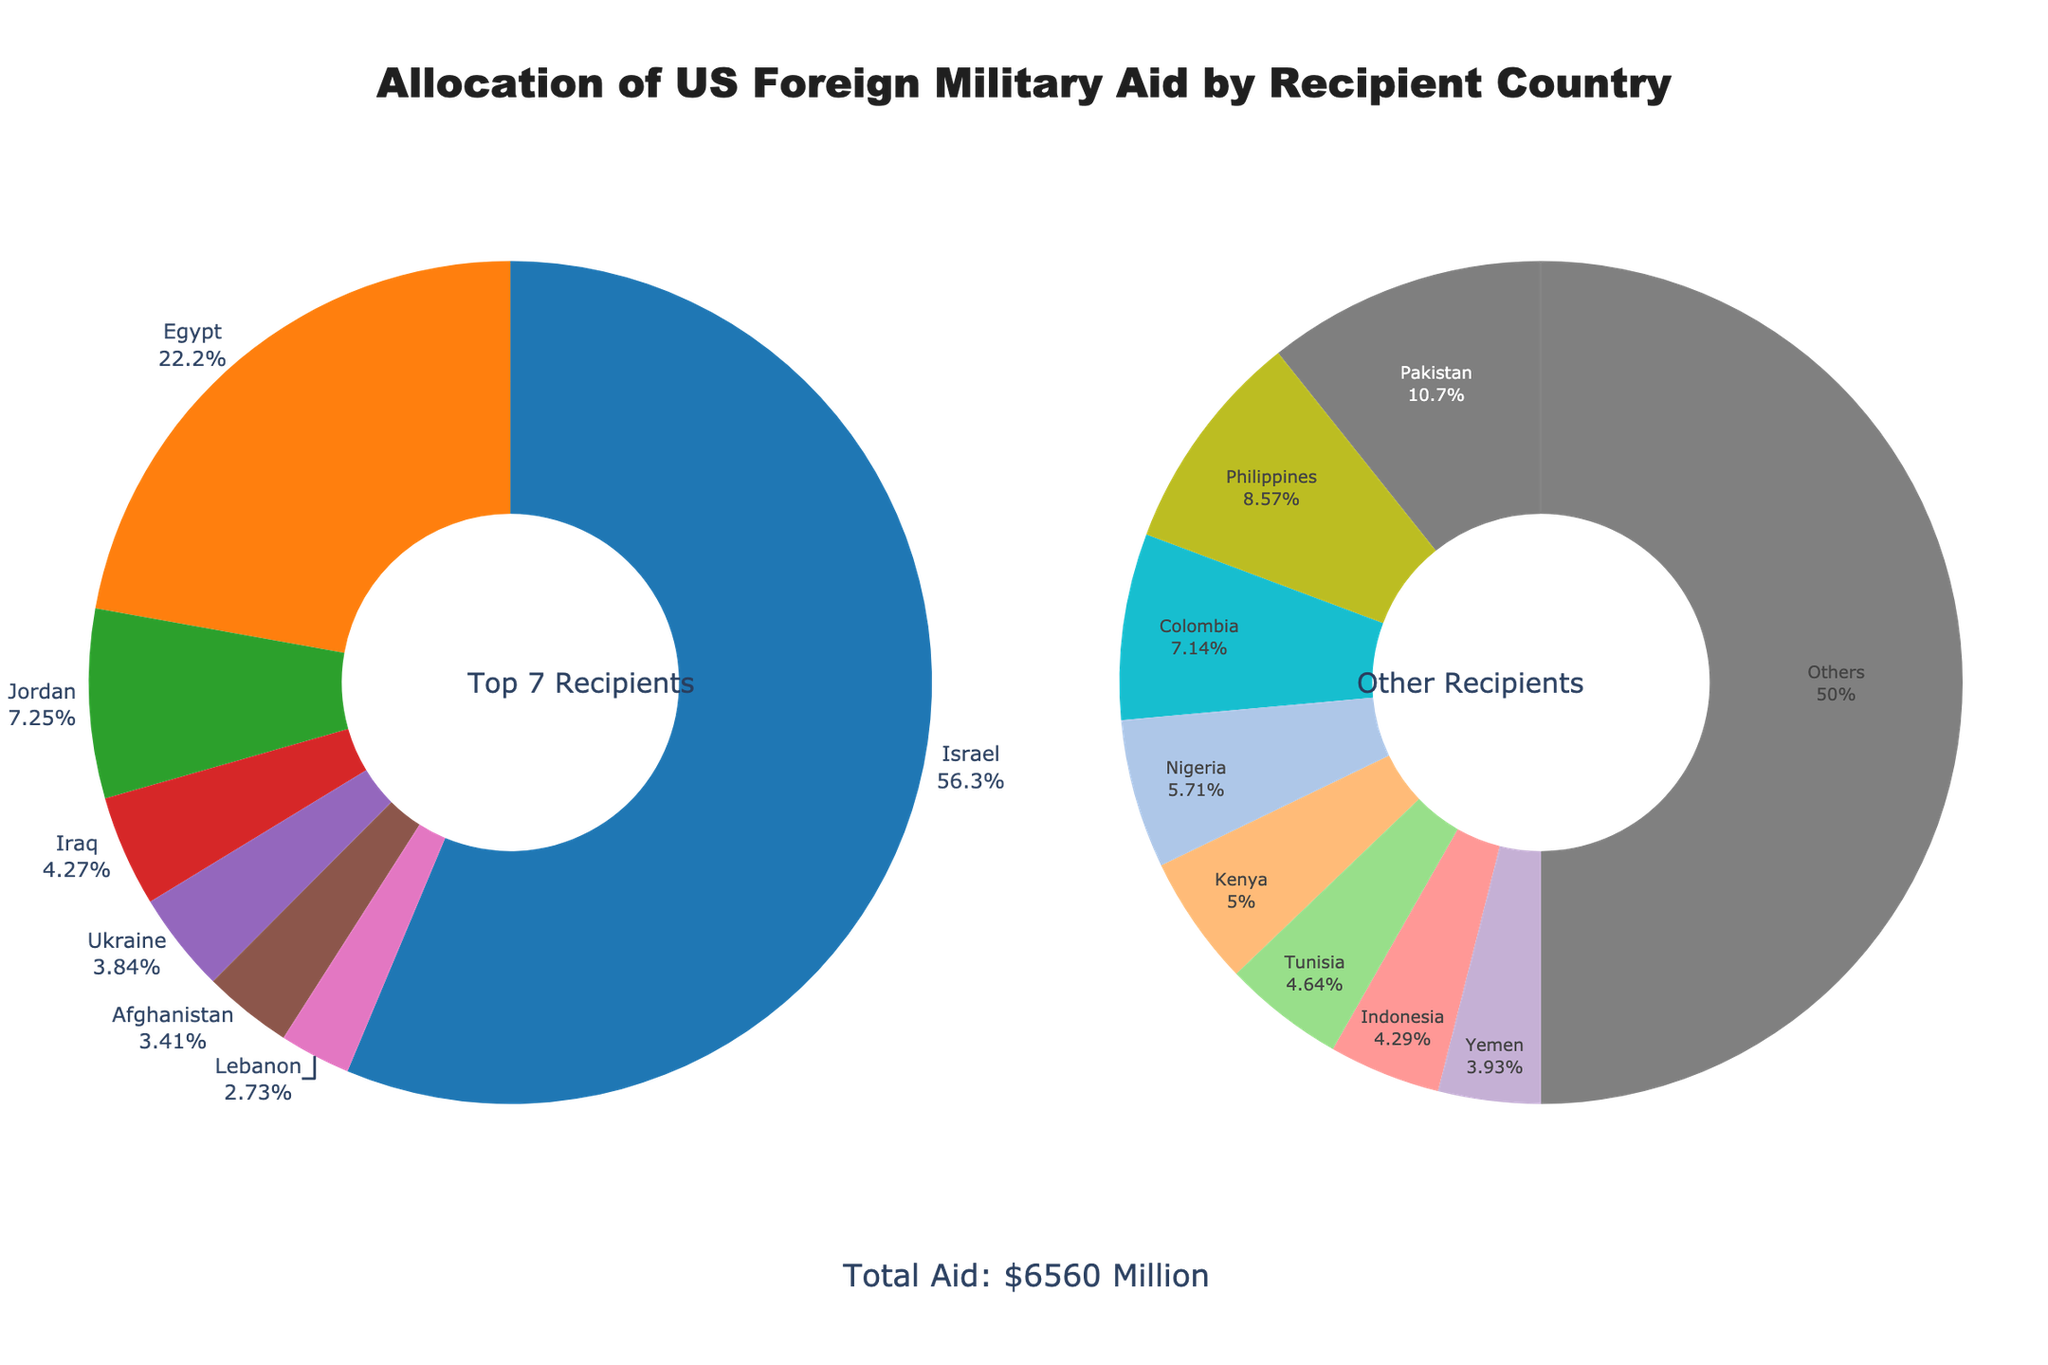Which country receives the highest amount of US foreign military aid? To determine the country receiving the highest amount of aid, look at the main pie chart for the country with the largest slice. Israel comes first with 3300 million USD.
Answer: Israel How much total aid is allocated to the top three recipient countries? Sum the aid amounts for Israel (3300 million USD), Egypt (1300 million USD), and Jordan (425 million USD). Total is 3300 + 1300 + 425 = 5025 million USD.
Answer: 5025 million USD What percentage of total aid does Israel receive? Refer to the percentage shown next to Israel in the main pie chart, or calculate by dividing Israel's aid (3300 million USD) by the total aid (6900 million USD) and then multiplying by 100.
Answer: 47.83% Which two countries receive almost equal amounts of aid? Compare aid amounts visually in the main and secondary pie charts. Pakistan and Philippines receive approximately equal amounts, 150 million USD and 120 million USD respectively.
Answer: Pakistan and Philippines What proportion of the total aid is categorized under "Other Recipients"? Find the second pie chart's slice labeled as "Others". Calculate by dividing the sum of those countries’ aid amounts (960 million USD) by total aid (6900 million USD) and convert to a percentage.
Answer: 13.91% What is the sum of aid given to countries in the "Others" category? The second pie chart visually summarizes "Others". Adding the aid amounts of all countries not in the top 7 gives the sum as 960 million USD. This total is shown as a slice in the "Others" pie chart.
Answer: 960 million USD Which country receives the least foreign military aid among the listed countries? The smallest slice in the secondary pie chart corresponds to Yemen, receiving 55 million USD.
Answer: Yemen How much more aid does Egypt receive compared to Ukraine? Subtract the aid amount for Ukraine (225 million USD) from Egypt’s aid amount (1300 million USD). Calculation: 1300 - 225 = 1075 million USD.
Answer: 1075 million USD Between Afghanistan and Lebanon, which country receives more aid and by what amount? Compare slices in the main pie chart: Lebanon receives 160 million USD while Afghanistan receives 200 million USD. Subtract: 200 - 160 = 40 million USD. Therefore, Afghanistan gets 40 million USD more.
Answer: Afghanistan, 40 million USD What is the combined percentage of aid received by Jordan and Iraq? Add the percentages from the main pie chart: Jordan receives 6.16% and Iraq 3.62%. Combined percentage is 6.16 + 3.62 = 9.78%.
Answer: 9.78% 